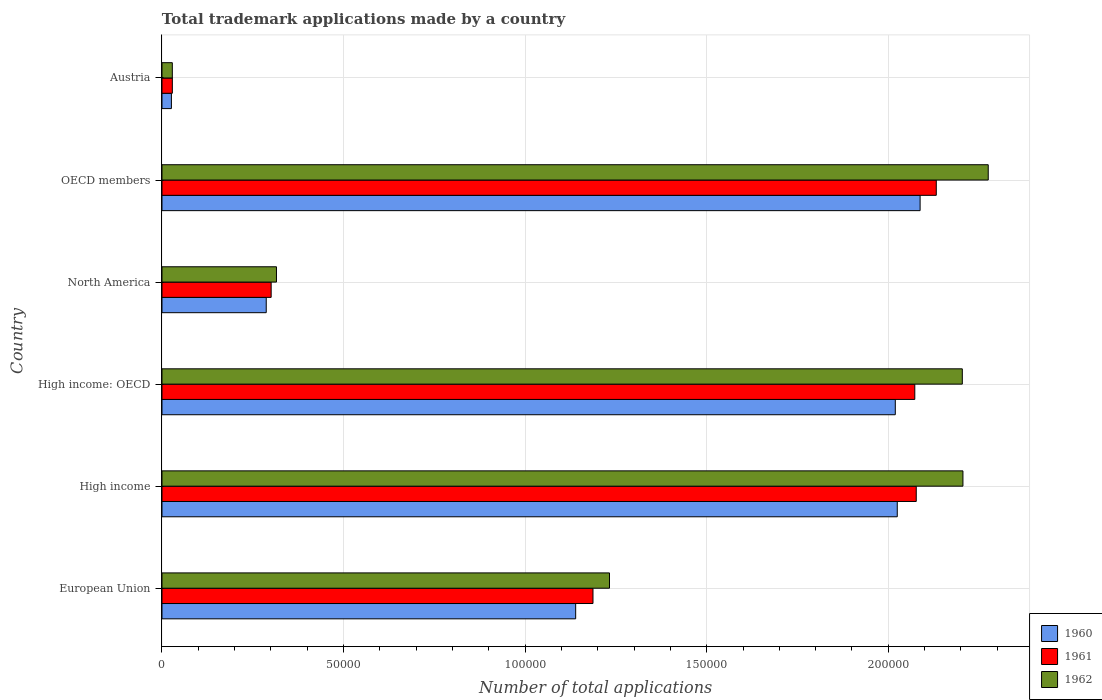How many different coloured bars are there?
Offer a terse response. 3. Are the number of bars on each tick of the Y-axis equal?
Ensure brevity in your answer.  Yes. How many bars are there on the 4th tick from the top?
Your answer should be compact. 3. How many bars are there on the 1st tick from the bottom?
Your answer should be compact. 3. In how many cases, is the number of bars for a given country not equal to the number of legend labels?
Keep it short and to the point. 0. What is the number of applications made by in 1961 in Austria?
Offer a terse response. 2852. Across all countries, what is the maximum number of applications made by in 1962?
Ensure brevity in your answer.  2.28e+05. Across all countries, what is the minimum number of applications made by in 1960?
Give a very brief answer. 2596. In which country was the number of applications made by in 1962 maximum?
Offer a very short reply. OECD members. In which country was the number of applications made by in 1961 minimum?
Provide a short and direct response. Austria. What is the total number of applications made by in 1961 in the graph?
Provide a succinct answer. 7.80e+05. What is the difference between the number of applications made by in 1962 in High income and that in OECD members?
Your response must be concise. -6969. What is the difference between the number of applications made by in 1961 in High income and the number of applications made by in 1960 in Austria?
Make the answer very short. 2.05e+05. What is the average number of applications made by in 1961 per country?
Offer a terse response. 1.30e+05. What is the difference between the number of applications made by in 1961 and number of applications made by in 1962 in High income: OECD?
Give a very brief answer. -1.31e+04. What is the ratio of the number of applications made by in 1960 in European Union to that in High income?
Offer a very short reply. 0.56. Is the number of applications made by in 1962 in Austria less than that in OECD members?
Your answer should be compact. Yes. What is the difference between the highest and the second highest number of applications made by in 1960?
Your response must be concise. 6293. What is the difference between the highest and the lowest number of applications made by in 1960?
Make the answer very short. 2.06e+05. In how many countries, is the number of applications made by in 1960 greater than the average number of applications made by in 1960 taken over all countries?
Offer a terse response. 3. What does the 3rd bar from the top in Austria represents?
Ensure brevity in your answer.  1960. What does the 1st bar from the bottom in High income represents?
Give a very brief answer. 1960. How many bars are there?
Your answer should be compact. 18. How many countries are there in the graph?
Offer a very short reply. 6. What is the difference between two consecutive major ticks on the X-axis?
Offer a very short reply. 5.00e+04. How many legend labels are there?
Your response must be concise. 3. How are the legend labels stacked?
Keep it short and to the point. Vertical. What is the title of the graph?
Keep it short and to the point. Total trademark applications made by a country. What is the label or title of the X-axis?
Your answer should be very brief. Number of total applications. What is the label or title of the Y-axis?
Keep it short and to the point. Country. What is the Number of total applications of 1960 in European Union?
Give a very brief answer. 1.14e+05. What is the Number of total applications of 1961 in European Union?
Make the answer very short. 1.19e+05. What is the Number of total applications of 1962 in European Union?
Provide a succinct answer. 1.23e+05. What is the Number of total applications in 1960 in High income?
Your answer should be compact. 2.02e+05. What is the Number of total applications in 1961 in High income?
Offer a very short reply. 2.08e+05. What is the Number of total applications of 1962 in High income?
Ensure brevity in your answer.  2.21e+05. What is the Number of total applications of 1960 in High income: OECD?
Offer a very short reply. 2.02e+05. What is the Number of total applications of 1961 in High income: OECD?
Your response must be concise. 2.07e+05. What is the Number of total applications of 1962 in High income: OECD?
Give a very brief answer. 2.20e+05. What is the Number of total applications of 1960 in North America?
Your answer should be compact. 2.87e+04. What is the Number of total applications in 1961 in North America?
Provide a succinct answer. 3.01e+04. What is the Number of total applications in 1962 in North America?
Make the answer very short. 3.15e+04. What is the Number of total applications of 1960 in OECD members?
Keep it short and to the point. 2.09e+05. What is the Number of total applications in 1961 in OECD members?
Give a very brief answer. 2.13e+05. What is the Number of total applications of 1962 in OECD members?
Your response must be concise. 2.28e+05. What is the Number of total applications in 1960 in Austria?
Provide a succinct answer. 2596. What is the Number of total applications of 1961 in Austria?
Provide a short and direct response. 2852. What is the Number of total applications of 1962 in Austria?
Make the answer very short. 2849. Across all countries, what is the maximum Number of total applications in 1960?
Make the answer very short. 2.09e+05. Across all countries, what is the maximum Number of total applications in 1961?
Keep it short and to the point. 2.13e+05. Across all countries, what is the maximum Number of total applications of 1962?
Provide a succinct answer. 2.28e+05. Across all countries, what is the minimum Number of total applications of 1960?
Provide a succinct answer. 2596. Across all countries, what is the minimum Number of total applications in 1961?
Give a very brief answer. 2852. Across all countries, what is the minimum Number of total applications in 1962?
Provide a succinct answer. 2849. What is the total Number of total applications of 1960 in the graph?
Your response must be concise. 7.58e+05. What is the total Number of total applications of 1961 in the graph?
Make the answer very short. 7.80e+05. What is the total Number of total applications of 1962 in the graph?
Offer a very short reply. 8.26e+05. What is the difference between the Number of total applications in 1960 in European Union and that in High income?
Your answer should be very brief. -8.86e+04. What is the difference between the Number of total applications in 1961 in European Union and that in High income?
Your answer should be very brief. -8.90e+04. What is the difference between the Number of total applications of 1962 in European Union and that in High income?
Provide a short and direct response. -9.73e+04. What is the difference between the Number of total applications of 1960 in European Union and that in High income: OECD?
Provide a succinct answer. -8.80e+04. What is the difference between the Number of total applications of 1961 in European Union and that in High income: OECD?
Provide a succinct answer. -8.86e+04. What is the difference between the Number of total applications of 1962 in European Union and that in High income: OECD?
Your answer should be compact. -9.72e+04. What is the difference between the Number of total applications of 1960 in European Union and that in North America?
Keep it short and to the point. 8.52e+04. What is the difference between the Number of total applications of 1961 in European Union and that in North America?
Offer a terse response. 8.86e+04. What is the difference between the Number of total applications of 1962 in European Union and that in North America?
Your answer should be compact. 9.17e+04. What is the difference between the Number of total applications of 1960 in European Union and that in OECD members?
Your answer should be compact. -9.49e+04. What is the difference between the Number of total applications of 1961 in European Union and that in OECD members?
Your answer should be compact. -9.45e+04. What is the difference between the Number of total applications of 1962 in European Union and that in OECD members?
Make the answer very short. -1.04e+05. What is the difference between the Number of total applications of 1960 in European Union and that in Austria?
Ensure brevity in your answer.  1.11e+05. What is the difference between the Number of total applications of 1961 in European Union and that in Austria?
Provide a short and direct response. 1.16e+05. What is the difference between the Number of total applications of 1962 in European Union and that in Austria?
Offer a very short reply. 1.20e+05. What is the difference between the Number of total applications of 1960 in High income and that in High income: OECD?
Ensure brevity in your answer.  540. What is the difference between the Number of total applications of 1961 in High income and that in High income: OECD?
Offer a terse response. 401. What is the difference between the Number of total applications in 1962 in High income and that in High income: OECD?
Provide a short and direct response. 170. What is the difference between the Number of total applications in 1960 in High income and that in North America?
Offer a very short reply. 1.74e+05. What is the difference between the Number of total applications in 1961 in High income and that in North America?
Provide a succinct answer. 1.78e+05. What is the difference between the Number of total applications of 1962 in High income and that in North America?
Make the answer very short. 1.89e+05. What is the difference between the Number of total applications of 1960 in High income and that in OECD members?
Give a very brief answer. -6293. What is the difference between the Number of total applications in 1961 in High income and that in OECD members?
Your answer should be compact. -5516. What is the difference between the Number of total applications in 1962 in High income and that in OECD members?
Give a very brief answer. -6969. What is the difference between the Number of total applications in 1960 in High income and that in Austria?
Provide a succinct answer. 2.00e+05. What is the difference between the Number of total applications of 1961 in High income and that in Austria?
Ensure brevity in your answer.  2.05e+05. What is the difference between the Number of total applications in 1962 in High income and that in Austria?
Keep it short and to the point. 2.18e+05. What is the difference between the Number of total applications in 1960 in High income: OECD and that in North America?
Your response must be concise. 1.73e+05. What is the difference between the Number of total applications in 1961 in High income: OECD and that in North America?
Make the answer very short. 1.77e+05. What is the difference between the Number of total applications of 1962 in High income: OECD and that in North America?
Your answer should be very brief. 1.89e+05. What is the difference between the Number of total applications in 1960 in High income: OECD and that in OECD members?
Make the answer very short. -6833. What is the difference between the Number of total applications of 1961 in High income: OECD and that in OECD members?
Your answer should be compact. -5917. What is the difference between the Number of total applications of 1962 in High income: OECD and that in OECD members?
Provide a short and direct response. -7139. What is the difference between the Number of total applications in 1960 in High income: OECD and that in Austria?
Your answer should be very brief. 1.99e+05. What is the difference between the Number of total applications of 1961 in High income: OECD and that in Austria?
Give a very brief answer. 2.04e+05. What is the difference between the Number of total applications of 1962 in High income: OECD and that in Austria?
Keep it short and to the point. 2.18e+05. What is the difference between the Number of total applications of 1960 in North America and that in OECD members?
Give a very brief answer. -1.80e+05. What is the difference between the Number of total applications in 1961 in North America and that in OECD members?
Keep it short and to the point. -1.83e+05. What is the difference between the Number of total applications in 1962 in North America and that in OECD members?
Your answer should be compact. -1.96e+05. What is the difference between the Number of total applications of 1960 in North America and that in Austria?
Give a very brief answer. 2.61e+04. What is the difference between the Number of total applications in 1961 in North America and that in Austria?
Keep it short and to the point. 2.72e+04. What is the difference between the Number of total applications in 1962 in North America and that in Austria?
Your response must be concise. 2.87e+04. What is the difference between the Number of total applications of 1960 in OECD members and that in Austria?
Ensure brevity in your answer.  2.06e+05. What is the difference between the Number of total applications of 1961 in OECD members and that in Austria?
Make the answer very short. 2.10e+05. What is the difference between the Number of total applications in 1962 in OECD members and that in Austria?
Offer a very short reply. 2.25e+05. What is the difference between the Number of total applications in 1960 in European Union and the Number of total applications in 1961 in High income?
Provide a succinct answer. -9.38e+04. What is the difference between the Number of total applications in 1960 in European Union and the Number of total applications in 1962 in High income?
Offer a terse response. -1.07e+05. What is the difference between the Number of total applications of 1961 in European Union and the Number of total applications of 1962 in High income?
Give a very brief answer. -1.02e+05. What is the difference between the Number of total applications of 1960 in European Union and the Number of total applications of 1961 in High income: OECD?
Ensure brevity in your answer.  -9.34e+04. What is the difference between the Number of total applications in 1960 in European Union and the Number of total applications in 1962 in High income: OECD?
Provide a succinct answer. -1.06e+05. What is the difference between the Number of total applications of 1961 in European Union and the Number of total applications of 1962 in High income: OECD?
Give a very brief answer. -1.02e+05. What is the difference between the Number of total applications in 1960 in European Union and the Number of total applications in 1961 in North America?
Offer a very short reply. 8.39e+04. What is the difference between the Number of total applications in 1960 in European Union and the Number of total applications in 1962 in North America?
Make the answer very short. 8.24e+04. What is the difference between the Number of total applications of 1961 in European Union and the Number of total applications of 1962 in North America?
Keep it short and to the point. 8.72e+04. What is the difference between the Number of total applications of 1960 in European Union and the Number of total applications of 1961 in OECD members?
Your answer should be very brief. -9.93e+04. What is the difference between the Number of total applications in 1960 in European Union and the Number of total applications in 1962 in OECD members?
Your response must be concise. -1.14e+05. What is the difference between the Number of total applications in 1961 in European Union and the Number of total applications in 1962 in OECD members?
Make the answer very short. -1.09e+05. What is the difference between the Number of total applications in 1960 in European Union and the Number of total applications in 1961 in Austria?
Provide a succinct answer. 1.11e+05. What is the difference between the Number of total applications in 1960 in European Union and the Number of total applications in 1962 in Austria?
Offer a very short reply. 1.11e+05. What is the difference between the Number of total applications of 1961 in European Union and the Number of total applications of 1962 in Austria?
Provide a succinct answer. 1.16e+05. What is the difference between the Number of total applications of 1960 in High income and the Number of total applications of 1961 in High income: OECD?
Offer a very short reply. -4828. What is the difference between the Number of total applications of 1960 in High income and the Number of total applications of 1962 in High income: OECD?
Your answer should be very brief. -1.79e+04. What is the difference between the Number of total applications of 1961 in High income and the Number of total applications of 1962 in High income: OECD?
Provide a short and direct response. -1.27e+04. What is the difference between the Number of total applications of 1960 in High income and the Number of total applications of 1961 in North America?
Keep it short and to the point. 1.72e+05. What is the difference between the Number of total applications of 1960 in High income and the Number of total applications of 1962 in North America?
Your answer should be compact. 1.71e+05. What is the difference between the Number of total applications in 1961 in High income and the Number of total applications in 1962 in North America?
Offer a terse response. 1.76e+05. What is the difference between the Number of total applications in 1960 in High income and the Number of total applications in 1961 in OECD members?
Provide a short and direct response. -1.07e+04. What is the difference between the Number of total applications of 1960 in High income and the Number of total applications of 1962 in OECD members?
Provide a short and direct response. -2.51e+04. What is the difference between the Number of total applications in 1961 in High income and the Number of total applications in 1962 in OECD members?
Give a very brief answer. -1.98e+04. What is the difference between the Number of total applications in 1960 in High income and the Number of total applications in 1961 in Austria?
Offer a very short reply. 2.00e+05. What is the difference between the Number of total applications of 1960 in High income and the Number of total applications of 1962 in Austria?
Offer a terse response. 2.00e+05. What is the difference between the Number of total applications of 1961 in High income and the Number of total applications of 1962 in Austria?
Make the answer very short. 2.05e+05. What is the difference between the Number of total applications of 1960 in High income: OECD and the Number of total applications of 1961 in North America?
Offer a terse response. 1.72e+05. What is the difference between the Number of total applications in 1960 in High income: OECD and the Number of total applications in 1962 in North America?
Make the answer very short. 1.70e+05. What is the difference between the Number of total applications in 1961 in High income: OECD and the Number of total applications in 1962 in North America?
Your answer should be compact. 1.76e+05. What is the difference between the Number of total applications of 1960 in High income: OECD and the Number of total applications of 1961 in OECD members?
Provide a short and direct response. -1.13e+04. What is the difference between the Number of total applications of 1960 in High income: OECD and the Number of total applications of 1962 in OECD members?
Provide a short and direct response. -2.56e+04. What is the difference between the Number of total applications of 1961 in High income: OECD and the Number of total applications of 1962 in OECD members?
Ensure brevity in your answer.  -2.02e+04. What is the difference between the Number of total applications of 1960 in High income: OECD and the Number of total applications of 1961 in Austria?
Make the answer very short. 1.99e+05. What is the difference between the Number of total applications of 1960 in High income: OECD and the Number of total applications of 1962 in Austria?
Provide a short and direct response. 1.99e+05. What is the difference between the Number of total applications of 1961 in High income: OECD and the Number of total applications of 1962 in Austria?
Offer a terse response. 2.04e+05. What is the difference between the Number of total applications of 1960 in North America and the Number of total applications of 1961 in OECD members?
Your answer should be compact. -1.85e+05. What is the difference between the Number of total applications of 1960 in North America and the Number of total applications of 1962 in OECD members?
Provide a succinct answer. -1.99e+05. What is the difference between the Number of total applications of 1961 in North America and the Number of total applications of 1962 in OECD members?
Offer a very short reply. -1.97e+05. What is the difference between the Number of total applications in 1960 in North America and the Number of total applications in 1961 in Austria?
Offer a terse response. 2.59e+04. What is the difference between the Number of total applications of 1960 in North America and the Number of total applications of 1962 in Austria?
Your response must be concise. 2.59e+04. What is the difference between the Number of total applications in 1961 in North America and the Number of total applications in 1962 in Austria?
Offer a very short reply. 2.72e+04. What is the difference between the Number of total applications in 1960 in OECD members and the Number of total applications in 1961 in Austria?
Offer a terse response. 2.06e+05. What is the difference between the Number of total applications of 1960 in OECD members and the Number of total applications of 1962 in Austria?
Provide a short and direct response. 2.06e+05. What is the difference between the Number of total applications in 1961 in OECD members and the Number of total applications in 1962 in Austria?
Give a very brief answer. 2.10e+05. What is the average Number of total applications in 1960 per country?
Give a very brief answer. 1.26e+05. What is the average Number of total applications of 1961 per country?
Keep it short and to the point. 1.30e+05. What is the average Number of total applications in 1962 per country?
Make the answer very short. 1.38e+05. What is the difference between the Number of total applications of 1960 and Number of total applications of 1961 in European Union?
Your answer should be very brief. -4767. What is the difference between the Number of total applications of 1960 and Number of total applications of 1962 in European Union?
Provide a short and direct response. -9317. What is the difference between the Number of total applications in 1961 and Number of total applications in 1962 in European Union?
Offer a terse response. -4550. What is the difference between the Number of total applications in 1960 and Number of total applications in 1961 in High income?
Keep it short and to the point. -5229. What is the difference between the Number of total applications of 1960 and Number of total applications of 1962 in High income?
Ensure brevity in your answer.  -1.81e+04. What is the difference between the Number of total applications of 1961 and Number of total applications of 1962 in High income?
Provide a short and direct response. -1.29e+04. What is the difference between the Number of total applications of 1960 and Number of total applications of 1961 in High income: OECD?
Provide a short and direct response. -5368. What is the difference between the Number of total applications of 1960 and Number of total applications of 1962 in High income: OECD?
Give a very brief answer. -1.85e+04. What is the difference between the Number of total applications in 1961 and Number of total applications in 1962 in High income: OECD?
Your answer should be compact. -1.31e+04. What is the difference between the Number of total applications of 1960 and Number of total applications of 1961 in North America?
Keep it short and to the point. -1355. What is the difference between the Number of total applications of 1960 and Number of total applications of 1962 in North America?
Provide a short and direct response. -2817. What is the difference between the Number of total applications in 1961 and Number of total applications in 1962 in North America?
Ensure brevity in your answer.  -1462. What is the difference between the Number of total applications in 1960 and Number of total applications in 1961 in OECD members?
Your answer should be very brief. -4452. What is the difference between the Number of total applications in 1960 and Number of total applications in 1962 in OECD members?
Offer a terse response. -1.88e+04. What is the difference between the Number of total applications in 1961 and Number of total applications in 1962 in OECD members?
Offer a very short reply. -1.43e+04. What is the difference between the Number of total applications in 1960 and Number of total applications in 1961 in Austria?
Give a very brief answer. -256. What is the difference between the Number of total applications of 1960 and Number of total applications of 1962 in Austria?
Give a very brief answer. -253. What is the ratio of the Number of total applications of 1960 in European Union to that in High income?
Provide a succinct answer. 0.56. What is the ratio of the Number of total applications of 1961 in European Union to that in High income?
Ensure brevity in your answer.  0.57. What is the ratio of the Number of total applications in 1962 in European Union to that in High income?
Provide a succinct answer. 0.56. What is the ratio of the Number of total applications in 1960 in European Union to that in High income: OECD?
Offer a terse response. 0.56. What is the ratio of the Number of total applications of 1961 in European Union to that in High income: OECD?
Offer a terse response. 0.57. What is the ratio of the Number of total applications of 1962 in European Union to that in High income: OECD?
Keep it short and to the point. 0.56. What is the ratio of the Number of total applications in 1960 in European Union to that in North America?
Offer a terse response. 3.97. What is the ratio of the Number of total applications in 1961 in European Union to that in North America?
Your answer should be compact. 3.95. What is the ratio of the Number of total applications in 1962 in European Union to that in North America?
Offer a very short reply. 3.91. What is the ratio of the Number of total applications in 1960 in European Union to that in OECD members?
Provide a short and direct response. 0.55. What is the ratio of the Number of total applications of 1961 in European Union to that in OECD members?
Provide a succinct answer. 0.56. What is the ratio of the Number of total applications in 1962 in European Union to that in OECD members?
Your response must be concise. 0.54. What is the ratio of the Number of total applications in 1960 in European Union to that in Austria?
Keep it short and to the point. 43.88. What is the ratio of the Number of total applications in 1961 in European Union to that in Austria?
Keep it short and to the point. 41.61. What is the ratio of the Number of total applications in 1962 in European Union to that in Austria?
Give a very brief answer. 43.26. What is the ratio of the Number of total applications of 1960 in High income to that in High income: OECD?
Make the answer very short. 1. What is the ratio of the Number of total applications in 1961 in High income to that in High income: OECD?
Offer a very short reply. 1. What is the ratio of the Number of total applications in 1962 in High income to that in High income: OECD?
Your answer should be very brief. 1. What is the ratio of the Number of total applications in 1960 in High income to that in North America?
Ensure brevity in your answer.  7.05. What is the ratio of the Number of total applications in 1961 in High income to that in North America?
Provide a succinct answer. 6.91. What is the ratio of the Number of total applications in 1962 in High income to that in North America?
Give a very brief answer. 7. What is the ratio of the Number of total applications in 1960 in High income to that in OECD members?
Provide a short and direct response. 0.97. What is the ratio of the Number of total applications in 1961 in High income to that in OECD members?
Give a very brief answer. 0.97. What is the ratio of the Number of total applications of 1962 in High income to that in OECD members?
Ensure brevity in your answer.  0.97. What is the ratio of the Number of total applications in 1960 in High income to that in Austria?
Keep it short and to the point. 78. What is the ratio of the Number of total applications of 1961 in High income to that in Austria?
Your response must be concise. 72.83. What is the ratio of the Number of total applications of 1962 in High income to that in Austria?
Offer a terse response. 77.42. What is the ratio of the Number of total applications of 1960 in High income: OECD to that in North America?
Your answer should be very brief. 7.03. What is the ratio of the Number of total applications in 1961 in High income: OECD to that in North America?
Keep it short and to the point. 6.9. What is the ratio of the Number of total applications of 1962 in High income: OECD to that in North America?
Provide a short and direct response. 6.99. What is the ratio of the Number of total applications of 1960 in High income: OECD to that in OECD members?
Provide a short and direct response. 0.97. What is the ratio of the Number of total applications in 1961 in High income: OECD to that in OECD members?
Your response must be concise. 0.97. What is the ratio of the Number of total applications of 1962 in High income: OECD to that in OECD members?
Provide a succinct answer. 0.97. What is the ratio of the Number of total applications in 1960 in High income: OECD to that in Austria?
Offer a very short reply. 77.79. What is the ratio of the Number of total applications of 1961 in High income: OECD to that in Austria?
Ensure brevity in your answer.  72.69. What is the ratio of the Number of total applications in 1962 in High income: OECD to that in Austria?
Keep it short and to the point. 77.36. What is the ratio of the Number of total applications of 1960 in North America to that in OECD members?
Your response must be concise. 0.14. What is the ratio of the Number of total applications of 1961 in North America to that in OECD members?
Make the answer very short. 0.14. What is the ratio of the Number of total applications of 1962 in North America to that in OECD members?
Offer a very short reply. 0.14. What is the ratio of the Number of total applications of 1960 in North America to that in Austria?
Give a very brief answer. 11.06. What is the ratio of the Number of total applications in 1961 in North America to that in Austria?
Your response must be concise. 10.54. What is the ratio of the Number of total applications of 1962 in North America to that in Austria?
Offer a very short reply. 11.07. What is the ratio of the Number of total applications in 1960 in OECD members to that in Austria?
Provide a succinct answer. 80.42. What is the ratio of the Number of total applications in 1961 in OECD members to that in Austria?
Make the answer very short. 74.76. What is the ratio of the Number of total applications in 1962 in OECD members to that in Austria?
Ensure brevity in your answer.  79.86. What is the difference between the highest and the second highest Number of total applications of 1960?
Give a very brief answer. 6293. What is the difference between the highest and the second highest Number of total applications in 1961?
Your answer should be very brief. 5516. What is the difference between the highest and the second highest Number of total applications of 1962?
Your answer should be compact. 6969. What is the difference between the highest and the lowest Number of total applications of 1960?
Ensure brevity in your answer.  2.06e+05. What is the difference between the highest and the lowest Number of total applications in 1961?
Your answer should be very brief. 2.10e+05. What is the difference between the highest and the lowest Number of total applications in 1962?
Offer a terse response. 2.25e+05. 